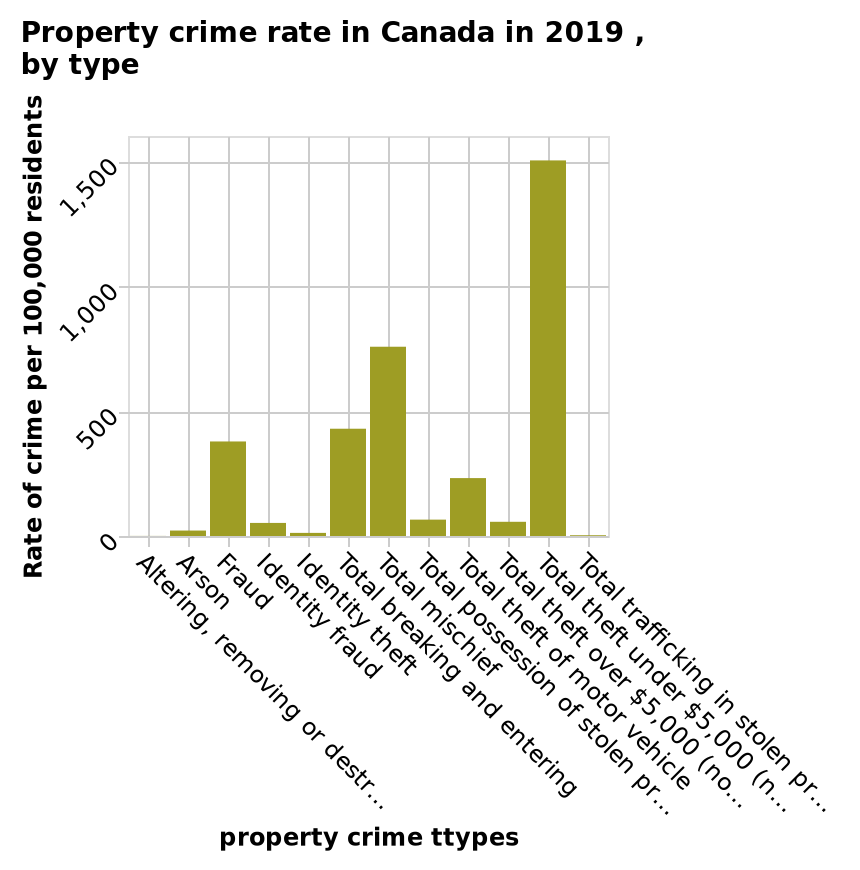<image>
What does the y-axis represent in the bar plot? The y-axis represents the rate of property crime per 100,000 residents. What is the range of total theft in terms of value? The description does not mention the range of total theft in terms of value. What unit of measurement is used for the y-axis? The y-axis is measured in the rate of property crime per 100,000 residents. please summary the statistics and relations of the chart The most common crime per 100,000 residents was total theft under $5000. The least common crimes were arson and identity theft. Total mischief was the second most common crime. The majority of crimes reported had rates of less than 500 per 100,000 residents. 